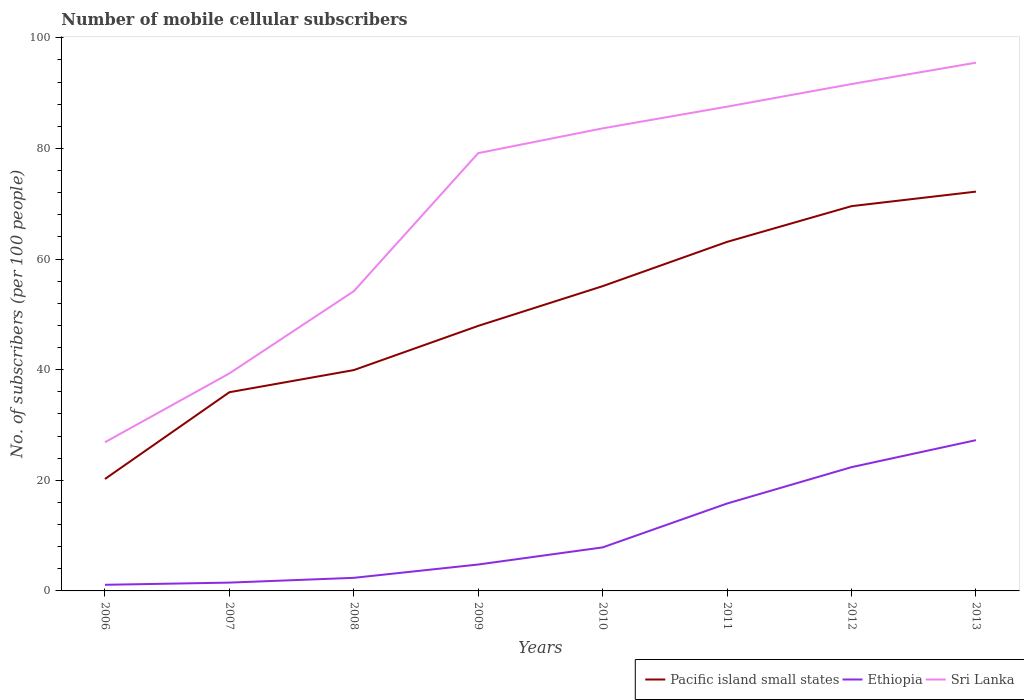Is the number of lines equal to the number of legend labels?
Provide a succinct answer. Yes. Across all years, what is the maximum number of mobile cellular subscribers in Sri Lanka?
Provide a short and direct response. 26.88. In which year was the number of mobile cellular subscribers in Sri Lanka maximum?
Your answer should be compact. 2006. What is the total number of mobile cellular subscribers in Ethiopia in the graph?
Offer a terse response. -22.48. What is the difference between the highest and the second highest number of mobile cellular subscribers in Pacific island small states?
Offer a very short reply. 51.95. What is the difference between the highest and the lowest number of mobile cellular subscribers in Pacific island small states?
Make the answer very short. 4. Is the number of mobile cellular subscribers in Pacific island small states strictly greater than the number of mobile cellular subscribers in Ethiopia over the years?
Provide a succinct answer. No. What is the difference between two consecutive major ticks on the Y-axis?
Give a very brief answer. 20. Are the values on the major ticks of Y-axis written in scientific E-notation?
Keep it short and to the point. No. Does the graph contain grids?
Ensure brevity in your answer.  No. Where does the legend appear in the graph?
Make the answer very short. Bottom right. What is the title of the graph?
Provide a succinct answer. Number of mobile cellular subscribers. Does "Nicaragua" appear as one of the legend labels in the graph?
Ensure brevity in your answer.  No. What is the label or title of the X-axis?
Your answer should be very brief. Years. What is the label or title of the Y-axis?
Offer a very short reply. No. of subscribers (per 100 people). What is the No. of subscribers (per 100 people) of Pacific island small states in 2006?
Offer a very short reply. 20.23. What is the No. of subscribers (per 100 people) of Ethiopia in 2006?
Your answer should be very brief. 1.11. What is the No. of subscribers (per 100 people) in Sri Lanka in 2006?
Your answer should be very brief. 26.88. What is the No. of subscribers (per 100 people) of Pacific island small states in 2007?
Provide a short and direct response. 35.92. What is the No. of subscribers (per 100 people) of Ethiopia in 2007?
Ensure brevity in your answer.  1.5. What is the No. of subscribers (per 100 people) of Sri Lanka in 2007?
Your response must be concise. 39.32. What is the No. of subscribers (per 100 people) of Pacific island small states in 2008?
Keep it short and to the point. 39.92. What is the No. of subscribers (per 100 people) of Ethiopia in 2008?
Provide a succinct answer. 2.37. What is the No. of subscribers (per 100 people) of Sri Lanka in 2008?
Your response must be concise. 54.19. What is the No. of subscribers (per 100 people) in Pacific island small states in 2009?
Ensure brevity in your answer.  47.92. What is the No. of subscribers (per 100 people) in Ethiopia in 2009?
Offer a terse response. 4.78. What is the No. of subscribers (per 100 people) of Sri Lanka in 2009?
Keep it short and to the point. 79.15. What is the No. of subscribers (per 100 people) in Pacific island small states in 2010?
Keep it short and to the point. 55.1. What is the No. of subscribers (per 100 people) of Ethiopia in 2010?
Provide a succinct answer. 7.87. What is the No. of subscribers (per 100 people) of Sri Lanka in 2010?
Offer a terse response. 83.62. What is the No. of subscribers (per 100 people) in Pacific island small states in 2011?
Your response must be concise. 63.1. What is the No. of subscribers (per 100 people) in Ethiopia in 2011?
Make the answer very short. 15.8. What is the No. of subscribers (per 100 people) in Sri Lanka in 2011?
Your response must be concise. 87.55. What is the No. of subscribers (per 100 people) of Pacific island small states in 2012?
Your response must be concise. 69.56. What is the No. of subscribers (per 100 people) of Ethiopia in 2012?
Give a very brief answer. 22.37. What is the No. of subscribers (per 100 people) in Sri Lanka in 2012?
Your answer should be very brief. 91.63. What is the No. of subscribers (per 100 people) in Pacific island small states in 2013?
Offer a very short reply. 72.18. What is the No. of subscribers (per 100 people) of Ethiopia in 2013?
Give a very brief answer. 27.25. What is the No. of subscribers (per 100 people) in Sri Lanka in 2013?
Make the answer very short. 95.5. Across all years, what is the maximum No. of subscribers (per 100 people) in Pacific island small states?
Offer a very short reply. 72.18. Across all years, what is the maximum No. of subscribers (per 100 people) of Ethiopia?
Provide a short and direct response. 27.25. Across all years, what is the maximum No. of subscribers (per 100 people) in Sri Lanka?
Offer a very short reply. 95.5. Across all years, what is the minimum No. of subscribers (per 100 people) of Pacific island small states?
Keep it short and to the point. 20.23. Across all years, what is the minimum No. of subscribers (per 100 people) in Ethiopia?
Make the answer very short. 1.11. Across all years, what is the minimum No. of subscribers (per 100 people) in Sri Lanka?
Provide a short and direct response. 26.88. What is the total No. of subscribers (per 100 people) of Pacific island small states in the graph?
Offer a terse response. 403.94. What is the total No. of subscribers (per 100 people) of Ethiopia in the graph?
Ensure brevity in your answer.  83.05. What is the total No. of subscribers (per 100 people) in Sri Lanka in the graph?
Your response must be concise. 557.83. What is the difference between the No. of subscribers (per 100 people) of Pacific island small states in 2006 and that in 2007?
Your answer should be very brief. -15.69. What is the difference between the No. of subscribers (per 100 people) in Ethiopia in 2006 and that in 2007?
Your answer should be compact. -0.4. What is the difference between the No. of subscribers (per 100 people) in Sri Lanka in 2006 and that in 2007?
Keep it short and to the point. -12.45. What is the difference between the No. of subscribers (per 100 people) of Pacific island small states in 2006 and that in 2008?
Offer a very short reply. -19.69. What is the difference between the No. of subscribers (per 100 people) of Ethiopia in 2006 and that in 2008?
Ensure brevity in your answer.  -1.26. What is the difference between the No. of subscribers (per 100 people) of Sri Lanka in 2006 and that in 2008?
Keep it short and to the point. -27.31. What is the difference between the No. of subscribers (per 100 people) in Pacific island small states in 2006 and that in 2009?
Keep it short and to the point. -27.68. What is the difference between the No. of subscribers (per 100 people) in Ethiopia in 2006 and that in 2009?
Provide a succinct answer. -3.67. What is the difference between the No. of subscribers (per 100 people) in Sri Lanka in 2006 and that in 2009?
Your answer should be compact. -52.27. What is the difference between the No. of subscribers (per 100 people) of Pacific island small states in 2006 and that in 2010?
Your answer should be very brief. -34.86. What is the difference between the No. of subscribers (per 100 people) in Ethiopia in 2006 and that in 2010?
Give a very brief answer. -6.76. What is the difference between the No. of subscribers (per 100 people) of Sri Lanka in 2006 and that in 2010?
Offer a terse response. -56.75. What is the difference between the No. of subscribers (per 100 people) of Pacific island small states in 2006 and that in 2011?
Offer a terse response. -42.87. What is the difference between the No. of subscribers (per 100 people) of Ethiopia in 2006 and that in 2011?
Provide a succinct answer. -14.7. What is the difference between the No. of subscribers (per 100 people) of Sri Lanka in 2006 and that in 2011?
Provide a short and direct response. -60.67. What is the difference between the No. of subscribers (per 100 people) in Pacific island small states in 2006 and that in 2012?
Keep it short and to the point. -49.33. What is the difference between the No. of subscribers (per 100 people) in Ethiopia in 2006 and that in 2012?
Your answer should be very brief. -21.27. What is the difference between the No. of subscribers (per 100 people) of Sri Lanka in 2006 and that in 2012?
Provide a succinct answer. -64.76. What is the difference between the No. of subscribers (per 100 people) in Pacific island small states in 2006 and that in 2013?
Offer a very short reply. -51.95. What is the difference between the No. of subscribers (per 100 people) of Ethiopia in 2006 and that in 2013?
Your answer should be compact. -26.15. What is the difference between the No. of subscribers (per 100 people) of Sri Lanka in 2006 and that in 2013?
Keep it short and to the point. -68.62. What is the difference between the No. of subscribers (per 100 people) in Pacific island small states in 2007 and that in 2008?
Make the answer very short. -4. What is the difference between the No. of subscribers (per 100 people) in Ethiopia in 2007 and that in 2008?
Give a very brief answer. -0.86. What is the difference between the No. of subscribers (per 100 people) of Sri Lanka in 2007 and that in 2008?
Your answer should be very brief. -14.86. What is the difference between the No. of subscribers (per 100 people) of Pacific island small states in 2007 and that in 2009?
Your response must be concise. -11.99. What is the difference between the No. of subscribers (per 100 people) in Ethiopia in 2007 and that in 2009?
Offer a terse response. -3.27. What is the difference between the No. of subscribers (per 100 people) in Sri Lanka in 2007 and that in 2009?
Make the answer very short. -39.82. What is the difference between the No. of subscribers (per 100 people) of Pacific island small states in 2007 and that in 2010?
Ensure brevity in your answer.  -19.18. What is the difference between the No. of subscribers (per 100 people) in Ethiopia in 2007 and that in 2010?
Your response must be concise. -6.37. What is the difference between the No. of subscribers (per 100 people) in Sri Lanka in 2007 and that in 2010?
Keep it short and to the point. -44.3. What is the difference between the No. of subscribers (per 100 people) in Pacific island small states in 2007 and that in 2011?
Your response must be concise. -27.18. What is the difference between the No. of subscribers (per 100 people) in Ethiopia in 2007 and that in 2011?
Offer a very short reply. -14.3. What is the difference between the No. of subscribers (per 100 people) in Sri Lanka in 2007 and that in 2011?
Provide a succinct answer. -48.22. What is the difference between the No. of subscribers (per 100 people) in Pacific island small states in 2007 and that in 2012?
Your answer should be very brief. -33.64. What is the difference between the No. of subscribers (per 100 people) of Ethiopia in 2007 and that in 2012?
Provide a short and direct response. -20.87. What is the difference between the No. of subscribers (per 100 people) of Sri Lanka in 2007 and that in 2012?
Ensure brevity in your answer.  -52.31. What is the difference between the No. of subscribers (per 100 people) in Pacific island small states in 2007 and that in 2013?
Offer a very short reply. -36.26. What is the difference between the No. of subscribers (per 100 people) of Ethiopia in 2007 and that in 2013?
Ensure brevity in your answer.  -25.75. What is the difference between the No. of subscribers (per 100 people) in Sri Lanka in 2007 and that in 2013?
Provide a succinct answer. -56.17. What is the difference between the No. of subscribers (per 100 people) of Pacific island small states in 2008 and that in 2009?
Give a very brief answer. -7.99. What is the difference between the No. of subscribers (per 100 people) of Ethiopia in 2008 and that in 2009?
Give a very brief answer. -2.41. What is the difference between the No. of subscribers (per 100 people) in Sri Lanka in 2008 and that in 2009?
Make the answer very short. -24.96. What is the difference between the No. of subscribers (per 100 people) of Pacific island small states in 2008 and that in 2010?
Provide a short and direct response. -15.18. What is the difference between the No. of subscribers (per 100 people) in Ethiopia in 2008 and that in 2010?
Your response must be concise. -5.5. What is the difference between the No. of subscribers (per 100 people) of Sri Lanka in 2008 and that in 2010?
Offer a terse response. -29.44. What is the difference between the No. of subscribers (per 100 people) of Pacific island small states in 2008 and that in 2011?
Your answer should be very brief. -23.18. What is the difference between the No. of subscribers (per 100 people) of Ethiopia in 2008 and that in 2011?
Keep it short and to the point. -13.44. What is the difference between the No. of subscribers (per 100 people) of Sri Lanka in 2008 and that in 2011?
Your answer should be compact. -33.36. What is the difference between the No. of subscribers (per 100 people) in Pacific island small states in 2008 and that in 2012?
Offer a very short reply. -29.64. What is the difference between the No. of subscribers (per 100 people) in Ethiopia in 2008 and that in 2012?
Provide a succinct answer. -20.01. What is the difference between the No. of subscribers (per 100 people) of Sri Lanka in 2008 and that in 2012?
Keep it short and to the point. -37.45. What is the difference between the No. of subscribers (per 100 people) in Pacific island small states in 2008 and that in 2013?
Offer a very short reply. -32.26. What is the difference between the No. of subscribers (per 100 people) of Ethiopia in 2008 and that in 2013?
Your answer should be very brief. -24.89. What is the difference between the No. of subscribers (per 100 people) of Sri Lanka in 2008 and that in 2013?
Your answer should be very brief. -41.31. What is the difference between the No. of subscribers (per 100 people) of Pacific island small states in 2009 and that in 2010?
Keep it short and to the point. -7.18. What is the difference between the No. of subscribers (per 100 people) in Ethiopia in 2009 and that in 2010?
Your answer should be compact. -3.09. What is the difference between the No. of subscribers (per 100 people) of Sri Lanka in 2009 and that in 2010?
Provide a succinct answer. -4.48. What is the difference between the No. of subscribers (per 100 people) in Pacific island small states in 2009 and that in 2011?
Your response must be concise. -15.19. What is the difference between the No. of subscribers (per 100 people) of Ethiopia in 2009 and that in 2011?
Ensure brevity in your answer.  -11.03. What is the difference between the No. of subscribers (per 100 people) of Sri Lanka in 2009 and that in 2011?
Provide a succinct answer. -8.4. What is the difference between the No. of subscribers (per 100 people) of Pacific island small states in 2009 and that in 2012?
Your response must be concise. -21.65. What is the difference between the No. of subscribers (per 100 people) of Ethiopia in 2009 and that in 2012?
Offer a terse response. -17.6. What is the difference between the No. of subscribers (per 100 people) of Sri Lanka in 2009 and that in 2012?
Keep it short and to the point. -12.49. What is the difference between the No. of subscribers (per 100 people) of Pacific island small states in 2009 and that in 2013?
Make the answer very short. -24.27. What is the difference between the No. of subscribers (per 100 people) in Ethiopia in 2009 and that in 2013?
Offer a very short reply. -22.48. What is the difference between the No. of subscribers (per 100 people) in Sri Lanka in 2009 and that in 2013?
Make the answer very short. -16.35. What is the difference between the No. of subscribers (per 100 people) in Pacific island small states in 2010 and that in 2011?
Keep it short and to the point. -8. What is the difference between the No. of subscribers (per 100 people) of Ethiopia in 2010 and that in 2011?
Keep it short and to the point. -7.93. What is the difference between the No. of subscribers (per 100 people) in Sri Lanka in 2010 and that in 2011?
Your response must be concise. -3.92. What is the difference between the No. of subscribers (per 100 people) in Pacific island small states in 2010 and that in 2012?
Offer a very short reply. -14.46. What is the difference between the No. of subscribers (per 100 people) of Ethiopia in 2010 and that in 2012?
Ensure brevity in your answer.  -14.51. What is the difference between the No. of subscribers (per 100 people) of Sri Lanka in 2010 and that in 2012?
Offer a terse response. -8.01. What is the difference between the No. of subscribers (per 100 people) in Pacific island small states in 2010 and that in 2013?
Your answer should be very brief. -17.09. What is the difference between the No. of subscribers (per 100 people) in Ethiopia in 2010 and that in 2013?
Your response must be concise. -19.39. What is the difference between the No. of subscribers (per 100 people) of Sri Lanka in 2010 and that in 2013?
Your answer should be compact. -11.87. What is the difference between the No. of subscribers (per 100 people) of Pacific island small states in 2011 and that in 2012?
Make the answer very short. -6.46. What is the difference between the No. of subscribers (per 100 people) of Ethiopia in 2011 and that in 2012?
Your answer should be compact. -6.57. What is the difference between the No. of subscribers (per 100 people) of Sri Lanka in 2011 and that in 2012?
Provide a short and direct response. -4.09. What is the difference between the No. of subscribers (per 100 people) of Pacific island small states in 2011 and that in 2013?
Your response must be concise. -9.08. What is the difference between the No. of subscribers (per 100 people) in Ethiopia in 2011 and that in 2013?
Your response must be concise. -11.45. What is the difference between the No. of subscribers (per 100 people) in Sri Lanka in 2011 and that in 2013?
Ensure brevity in your answer.  -7.95. What is the difference between the No. of subscribers (per 100 people) of Pacific island small states in 2012 and that in 2013?
Give a very brief answer. -2.62. What is the difference between the No. of subscribers (per 100 people) of Ethiopia in 2012 and that in 2013?
Give a very brief answer. -4.88. What is the difference between the No. of subscribers (per 100 people) of Sri Lanka in 2012 and that in 2013?
Your answer should be very brief. -3.86. What is the difference between the No. of subscribers (per 100 people) in Pacific island small states in 2006 and the No. of subscribers (per 100 people) in Ethiopia in 2007?
Your answer should be compact. 18.73. What is the difference between the No. of subscribers (per 100 people) of Pacific island small states in 2006 and the No. of subscribers (per 100 people) of Sri Lanka in 2007?
Make the answer very short. -19.09. What is the difference between the No. of subscribers (per 100 people) of Ethiopia in 2006 and the No. of subscribers (per 100 people) of Sri Lanka in 2007?
Ensure brevity in your answer.  -38.22. What is the difference between the No. of subscribers (per 100 people) in Pacific island small states in 2006 and the No. of subscribers (per 100 people) in Ethiopia in 2008?
Make the answer very short. 17.87. What is the difference between the No. of subscribers (per 100 people) of Pacific island small states in 2006 and the No. of subscribers (per 100 people) of Sri Lanka in 2008?
Your answer should be compact. -33.95. What is the difference between the No. of subscribers (per 100 people) in Ethiopia in 2006 and the No. of subscribers (per 100 people) in Sri Lanka in 2008?
Keep it short and to the point. -53.08. What is the difference between the No. of subscribers (per 100 people) of Pacific island small states in 2006 and the No. of subscribers (per 100 people) of Ethiopia in 2009?
Ensure brevity in your answer.  15.46. What is the difference between the No. of subscribers (per 100 people) in Pacific island small states in 2006 and the No. of subscribers (per 100 people) in Sri Lanka in 2009?
Give a very brief answer. -58.91. What is the difference between the No. of subscribers (per 100 people) of Ethiopia in 2006 and the No. of subscribers (per 100 people) of Sri Lanka in 2009?
Offer a terse response. -78.04. What is the difference between the No. of subscribers (per 100 people) of Pacific island small states in 2006 and the No. of subscribers (per 100 people) of Ethiopia in 2010?
Your response must be concise. 12.36. What is the difference between the No. of subscribers (per 100 people) of Pacific island small states in 2006 and the No. of subscribers (per 100 people) of Sri Lanka in 2010?
Provide a succinct answer. -63.39. What is the difference between the No. of subscribers (per 100 people) in Ethiopia in 2006 and the No. of subscribers (per 100 people) in Sri Lanka in 2010?
Ensure brevity in your answer.  -82.52. What is the difference between the No. of subscribers (per 100 people) of Pacific island small states in 2006 and the No. of subscribers (per 100 people) of Ethiopia in 2011?
Provide a succinct answer. 4.43. What is the difference between the No. of subscribers (per 100 people) of Pacific island small states in 2006 and the No. of subscribers (per 100 people) of Sri Lanka in 2011?
Keep it short and to the point. -67.31. What is the difference between the No. of subscribers (per 100 people) of Ethiopia in 2006 and the No. of subscribers (per 100 people) of Sri Lanka in 2011?
Make the answer very short. -86.44. What is the difference between the No. of subscribers (per 100 people) in Pacific island small states in 2006 and the No. of subscribers (per 100 people) in Ethiopia in 2012?
Your answer should be compact. -2.14. What is the difference between the No. of subscribers (per 100 people) in Pacific island small states in 2006 and the No. of subscribers (per 100 people) in Sri Lanka in 2012?
Your answer should be compact. -71.4. What is the difference between the No. of subscribers (per 100 people) in Ethiopia in 2006 and the No. of subscribers (per 100 people) in Sri Lanka in 2012?
Give a very brief answer. -90.53. What is the difference between the No. of subscribers (per 100 people) in Pacific island small states in 2006 and the No. of subscribers (per 100 people) in Ethiopia in 2013?
Provide a succinct answer. -7.02. What is the difference between the No. of subscribers (per 100 people) of Pacific island small states in 2006 and the No. of subscribers (per 100 people) of Sri Lanka in 2013?
Your answer should be very brief. -75.26. What is the difference between the No. of subscribers (per 100 people) in Ethiopia in 2006 and the No. of subscribers (per 100 people) in Sri Lanka in 2013?
Provide a succinct answer. -94.39. What is the difference between the No. of subscribers (per 100 people) in Pacific island small states in 2007 and the No. of subscribers (per 100 people) in Ethiopia in 2008?
Make the answer very short. 33.56. What is the difference between the No. of subscribers (per 100 people) in Pacific island small states in 2007 and the No. of subscribers (per 100 people) in Sri Lanka in 2008?
Provide a succinct answer. -18.26. What is the difference between the No. of subscribers (per 100 people) in Ethiopia in 2007 and the No. of subscribers (per 100 people) in Sri Lanka in 2008?
Ensure brevity in your answer.  -52.68. What is the difference between the No. of subscribers (per 100 people) of Pacific island small states in 2007 and the No. of subscribers (per 100 people) of Ethiopia in 2009?
Your answer should be very brief. 31.15. What is the difference between the No. of subscribers (per 100 people) in Pacific island small states in 2007 and the No. of subscribers (per 100 people) in Sri Lanka in 2009?
Offer a terse response. -43.22. What is the difference between the No. of subscribers (per 100 people) of Ethiopia in 2007 and the No. of subscribers (per 100 people) of Sri Lanka in 2009?
Provide a short and direct response. -77.64. What is the difference between the No. of subscribers (per 100 people) in Pacific island small states in 2007 and the No. of subscribers (per 100 people) in Ethiopia in 2010?
Provide a succinct answer. 28.05. What is the difference between the No. of subscribers (per 100 people) of Pacific island small states in 2007 and the No. of subscribers (per 100 people) of Sri Lanka in 2010?
Your answer should be very brief. -47.7. What is the difference between the No. of subscribers (per 100 people) in Ethiopia in 2007 and the No. of subscribers (per 100 people) in Sri Lanka in 2010?
Your answer should be very brief. -82.12. What is the difference between the No. of subscribers (per 100 people) in Pacific island small states in 2007 and the No. of subscribers (per 100 people) in Ethiopia in 2011?
Your response must be concise. 20.12. What is the difference between the No. of subscribers (per 100 people) in Pacific island small states in 2007 and the No. of subscribers (per 100 people) in Sri Lanka in 2011?
Ensure brevity in your answer.  -51.62. What is the difference between the No. of subscribers (per 100 people) of Ethiopia in 2007 and the No. of subscribers (per 100 people) of Sri Lanka in 2011?
Your response must be concise. -86.04. What is the difference between the No. of subscribers (per 100 people) in Pacific island small states in 2007 and the No. of subscribers (per 100 people) in Ethiopia in 2012?
Make the answer very short. 13.55. What is the difference between the No. of subscribers (per 100 people) in Pacific island small states in 2007 and the No. of subscribers (per 100 people) in Sri Lanka in 2012?
Offer a terse response. -55.71. What is the difference between the No. of subscribers (per 100 people) in Ethiopia in 2007 and the No. of subscribers (per 100 people) in Sri Lanka in 2012?
Provide a succinct answer. -90.13. What is the difference between the No. of subscribers (per 100 people) in Pacific island small states in 2007 and the No. of subscribers (per 100 people) in Ethiopia in 2013?
Provide a short and direct response. 8.67. What is the difference between the No. of subscribers (per 100 people) in Pacific island small states in 2007 and the No. of subscribers (per 100 people) in Sri Lanka in 2013?
Your answer should be compact. -59.57. What is the difference between the No. of subscribers (per 100 people) of Ethiopia in 2007 and the No. of subscribers (per 100 people) of Sri Lanka in 2013?
Ensure brevity in your answer.  -93.99. What is the difference between the No. of subscribers (per 100 people) of Pacific island small states in 2008 and the No. of subscribers (per 100 people) of Ethiopia in 2009?
Your answer should be very brief. 35.15. What is the difference between the No. of subscribers (per 100 people) of Pacific island small states in 2008 and the No. of subscribers (per 100 people) of Sri Lanka in 2009?
Give a very brief answer. -39.22. What is the difference between the No. of subscribers (per 100 people) of Ethiopia in 2008 and the No. of subscribers (per 100 people) of Sri Lanka in 2009?
Keep it short and to the point. -76.78. What is the difference between the No. of subscribers (per 100 people) of Pacific island small states in 2008 and the No. of subscribers (per 100 people) of Ethiopia in 2010?
Provide a succinct answer. 32.05. What is the difference between the No. of subscribers (per 100 people) of Pacific island small states in 2008 and the No. of subscribers (per 100 people) of Sri Lanka in 2010?
Ensure brevity in your answer.  -43.7. What is the difference between the No. of subscribers (per 100 people) in Ethiopia in 2008 and the No. of subscribers (per 100 people) in Sri Lanka in 2010?
Your answer should be very brief. -81.26. What is the difference between the No. of subscribers (per 100 people) in Pacific island small states in 2008 and the No. of subscribers (per 100 people) in Ethiopia in 2011?
Your answer should be very brief. 24.12. What is the difference between the No. of subscribers (per 100 people) of Pacific island small states in 2008 and the No. of subscribers (per 100 people) of Sri Lanka in 2011?
Ensure brevity in your answer.  -47.62. What is the difference between the No. of subscribers (per 100 people) of Ethiopia in 2008 and the No. of subscribers (per 100 people) of Sri Lanka in 2011?
Provide a succinct answer. -85.18. What is the difference between the No. of subscribers (per 100 people) in Pacific island small states in 2008 and the No. of subscribers (per 100 people) in Ethiopia in 2012?
Offer a very short reply. 17.55. What is the difference between the No. of subscribers (per 100 people) of Pacific island small states in 2008 and the No. of subscribers (per 100 people) of Sri Lanka in 2012?
Provide a succinct answer. -51.71. What is the difference between the No. of subscribers (per 100 people) of Ethiopia in 2008 and the No. of subscribers (per 100 people) of Sri Lanka in 2012?
Offer a terse response. -89.27. What is the difference between the No. of subscribers (per 100 people) of Pacific island small states in 2008 and the No. of subscribers (per 100 people) of Ethiopia in 2013?
Provide a succinct answer. 12.67. What is the difference between the No. of subscribers (per 100 people) of Pacific island small states in 2008 and the No. of subscribers (per 100 people) of Sri Lanka in 2013?
Provide a succinct answer. -55.57. What is the difference between the No. of subscribers (per 100 people) of Ethiopia in 2008 and the No. of subscribers (per 100 people) of Sri Lanka in 2013?
Offer a terse response. -93.13. What is the difference between the No. of subscribers (per 100 people) of Pacific island small states in 2009 and the No. of subscribers (per 100 people) of Ethiopia in 2010?
Provide a succinct answer. 40.05. What is the difference between the No. of subscribers (per 100 people) of Pacific island small states in 2009 and the No. of subscribers (per 100 people) of Sri Lanka in 2010?
Your response must be concise. -35.71. What is the difference between the No. of subscribers (per 100 people) in Ethiopia in 2009 and the No. of subscribers (per 100 people) in Sri Lanka in 2010?
Keep it short and to the point. -78.85. What is the difference between the No. of subscribers (per 100 people) of Pacific island small states in 2009 and the No. of subscribers (per 100 people) of Ethiopia in 2011?
Make the answer very short. 32.11. What is the difference between the No. of subscribers (per 100 people) in Pacific island small states in 2009 and the No. of subscribers (per 100 people) in Sri Lanka in 2011?
Your answer should be very brief. -39.63. What is the difference between the No. of subscribers (per 100 people) in Ethiopia in 2009 and the No. of subscribers (per 100 people) in Sri Lanka in 2011?
Your answer should be compact. -82.77. What is the difference between the No. of subscribers (per 100 people) in Pacific island small states in 2009 and the No. of subscribers (per 100 people) in Ethiopia in 2012?
Offer a terse response. 25.54. What is the difference between the No. of subscribers (per 100 people) in Pacific island small states in 2009 and the No. of subscribers (per 100 people) in Sri Lanka in 2012?
Keep it short and to the point. -43.72. What is the difference between the No. of subscribers (per 100 people) in Ethiopia in 2009 and the No. of subscribers (per 100 people) in Sri Lanka in 2012?
Offer a very short reply. -86.86. What is the difference between the No. of subscribers (per 100 people) in Pacific island small states in 2009 and the No. of subscribers (per 100 people) in Ethiopia in 2013?
Keep it short and to the point. 20.66. What is the difference between the No. of subscribers (per 100 people) in Pacific island small states in 2009 and the No. of subscribers (per 100 people) in Sri Lanka in 2013?
Ensure brevity in your answer.  -47.58. What is the difference between the No. of subscribers (per 100 people) in Ethiopia in 2009 and the No. of subscribers (per 100 people) in Sri Lanka in 2013?
Ensure brevity in your answer.  -90.72. What is the difference between the No. of subscribers (per 100 people) in Pacific island small states in 2010 and the No. of subscribers (per 100 people) in Ethiopia in 2011?
Ensure brevity in your answer.  39.29. What is the difference between the No. of subscribers (per 100 people) of Pacific island small states in 2010 and the No. of subscribers (per 100 people) of Sri Lanka in 2011?
Offer a very short reply. -32.45. What is the difference between the No. of subscribers (per 100 people) in Ethiopia in 2010 and the No. of subscribers (per 100 people) in Sri Lanka in 2011?
Ensure brevity in your answer.  -79.68. What is the difference between the No. of subscribers (per 100 people) in Pacific island small states in 2010 and the No. of subscribers (per 100 people) in Ethiopia in 2012?
Provide a short and direct response. 32.72. What is the difference between the No. of subscribers (per 100 people) in Pacific island small states in 2010 and the No. of subscribers (per 100 people) in Sri Lanka in 2012?
Offer a terse response. -36.54. What is the difference between the No. of subscribers (per 100 people) of Ethiopia in 2010 and the No. of subscribers (per 100 people) of Sri Lanka in 2012?
Keep it short and to the point. -83.76. What is the difference between the No. of subscribers (per 100 people) in Pacific island small states in 2010 and the No. of subscribers (per 100 people) in Ethiopia in 2013?
Ensure brevity in your answer.  27.84. What is the difference between the No. of subscribers (per 100 people) in Pacific island small states in 2010 and the No. of subscribers (per 100 people) in Sri Lanka in 2013?
Provide a succinct answer. -40.4. What is the difference between the No. of subscribers (per 100 people) in Ethiopia in 2010 and the No. of subscribers (per 100 people) in Sri Lanka in 2013?
Your answer should be very brief. -87.63. What is the difference between the No. of subscribers (per 100 people) in Pacific island small states in 2011 and the No. of subscribers (per 100 people) in Ethiopia in 2012?
Give a very brief answer. 40.73. What is the difference between the No. of subscribers (per 100 people) of Pacific island small states in 2011 and the No. of subscribers (per 100 people) of Sri Lanka in 2012?
Offer a terse response. -28.53. What is the difference between the No. of subscribers (per 100 people) in Ethiopia in 2011 and the No. of subscribers (per 100 people) in Sri Lanka in 2012?
Provide a short and direct response. -75.83. What is the difference between the No. of subscribers (per 100 people) of Pacific island small states in 2011 and the No. of subscribers (per 100 people) of Ethiopia in 2013?
Keep it short and to the point. 35.85. What is the difference between the No. of subscribers (per 100 people) in Pacific island small states in 2011 and the No. of subscribers (per 100 people) in Sri Lanka in 2013?
Your response must be concise. -32.4. What is the difference between the No. of subscribers (per 100 people) of Ethiopia in 2011 and the No. of subscribers (per 100 people) of Sri Lanka in 2013?
Offer a terse response. -79.69. What is the difference between the No. of subscribers (per 100 people) in Pacific island small states in 2012 and the No. of subscribers (per 100 people) in Ethiopia in 2013?
Make the answer very short. 42.31. What is the difference between the No. of subscribers (per 100 people) of Pacific island small states in 2012 and the No. of subscribers (per 100 people) of Sri Lanka in 2013?
Ensure brevity in your answer.  -25.93. What is the difference between the No. of subscribers (per 100 people) of Ethiopia in 2012 and the No. of subscribers (per 100 people) of Sri Lanka in 2013?
Offer a terse response. -73.12. What is the average No. of subscribers (per 100 people) in Pacific island small states per year?
Offer a terse response. 50.49. What is the average No. of subscribers (per 100 people) in Ethiopia per year?
Offer a terse response. 10.38. What is the average No. of subscribers (per 100 people) of Sri Lanka per year?
Offer a very short reply. 69.73. In the year 2006, what is the difference between the No. of subscribers (per 100 people) in Pacific island small states and No. of subscribers (per 100 people) in Ethiopia?
Offer a very short reply. 19.13. In the year 2006, what is the difference between the No. of subscribers (per 100 people) in Pacific island small states and No. of subscribers (per 100 people) in Sri Lanka?
Provide a succinct answer. -6.64. In the year 2006, what is the difference between the No. of subscribers (per 100 people) of Ethiopia and No. of subscribers (per 100 people) of Sri Lanka?
Ensure brevity in your answer.  -25.77. In the year 2007, what is the difference between the No. of subscribers (per 100 people) of Pacific island small states and No. of subscribers (per 100 people) of Ethiopia?
Offer a very short reply. 34.42. In the year 2007, what is the difference between the No. of subscribers (per 100 people) of Pacific island small states and No. of subscribers (per 100 people) of Sri Lanka?
Ensure brevity in your answer.  -3.4. In the year 2007, what is the difference between the No. of subscribers (per 100 people) of Ethiopia and No. of subscribers (per 100 people) of Sri Lanka?
Provide a short and direct response. -37.82. In the year 2008, what is the difference between the No. of subscribers (per 100 people) of Pacific island small states and No. of subscribers (per 100 people) of Ethiopia?
Provide a succinct answer. 37.56. In the year 2008, what is the difference between the No. of subscribers (per 100 people) in Pacific island small states and No. of subscribers (per 100 people) in Sri Lanka?
Provide a short and direct response. -14.26. In the year 2008, what is the difference between the No. of subscribers (per 100 people) in Ethiopia and No. of subscribers (per 100 people) in Sri Lanka?
Provide a succinct answer. -51.82. In the year 2009, what is the difference between the No. of subscribers (per 100 people) in Pacific island small states and No. of subscribers (per 100 people) in Ethiopia?
Provide a succinct answer. 43.14. In the year 2009, what is the difference between the No. of subscribers (per 100 people) in Pacific island small states and No. of subscribers (per 100 people) in Sri Lanka?
Offer a very short reply. -31.23. In the year 2009, what is the difference between the No. of subscribers (per 100 people) of Ethiopia and No. of subscribers (per 100 people) of Sri Lanka?
Give a very brief answer. -74.37. In the year 2010, what is the difference between the No. of subscribers (per 100 people) in Pacific island small states and No. of subscribers (per 100 people) in Ethiopia?
Provide a succinct answer. 47.23. In the year 2010, what is the difference between the No. of subscribers (per 100 people) of Pacific island small states and No. of subscribers (per 100 people) of Sri Lanka?
Your answer should be compact. -28.53. In the year 2010, what is the difference between the No. of subscribers (per 100 people) in Ethiopia and No. of subscribers (per 100 people) in Sri Lanka?
Keep it short and to the point. -75.75. In the year 2011, what is the difference between the No. of subscribers (per 100 people) in Pacific island small states and No. of subscribers (per 100 people) in Ethiopia?
Offer a very short reply. 47.3. In the year 2011, what is the difference between the No. of subscribers (per 100 people) in Pacific island small states and No. of subscribers (per 100 people) in Sri Lanka?
Offer a terse response. -24.44. In the year 2011, what is the difference between the No. of subscribers (per 100 people) in Ethiopia and No. of subscribers (per 100 people) in Sri Lanka?
Keep it short and to the point. -71.74. In the year 2012, what is the difference between the No. of subscribers (per 100 people) in Pacific island small states and No. of subscribers (per 100 people) in Ethiopia?
Your response must be concise. 47.19. In the year 2012, what is the difference between the No. of subscribers (per 100 people) in Pacific island small states and No. of subscribers (per 100 people) in Sri Lanka?
Offer a terse response. -22.07. In the year 2012, what is the difference between the No. of subscribers (per 100 people) in Ethiopia and No. of subscribers (per 100 people) in Sri Lanka?
Offer a terse response. -69.26. In the year 2013, what is the difference between the No. of subscribers (per 100 people) in Pacific island small states and No. of subscribers (per 100 people) in Ethiopia?
Provide a short and direct response. 44.93. In the year 2013, what is the difference between the No. of subscribers (per 100 people) of Pacific island small states and No. of subscribers (per 100 people) of Sri Lanka?
Your answer should be compact. -23.31. In the year 2013, what is the difference between the No. of subscribers (per 100 people) of Ethiopia and No. of subscribers (per 100 people) of Sri Lanka?
Offer a terse response. -68.24. What is the ratio of the No. of subscribers (per 100 people) in Pacific island small states in 2006 to that in 2007?
Your response must be concise. 0.56. What is the ratio of the No. of subscribers (per 100 people) in Ethiopia in 2006 to that in 2007?
Make the answer very short. 0.74. What is the ratio of the No. of subscribers (per 100 people) of Sri Lanka in 2006 to that in 2007?
Offer a terse response. 0.68. What is the ratio of the No. of subscribers (per 100 people) in Pacific island small states in 2006 to that in 2008?
Make the answer very short. 0.51. What is the ratio of the No. of subscribers (per 100 people) of Ethiopia in 2006 to that in 2008?
Your answer should be very brief. 0.47. What is the ratio of the No. of subscribers (per 100 people) in Sri Lanka in 2006 to that in 2008?
Your answer should be very brief. 0.5. What is the ratio of the No. of subscribers (per 100 people) in Pacific island small states in 2006 to that in 2009?
Keep it short and to the point. 0.42. What is the ratio of the No. of subscribers (per 100 people) in Ethiopia in 2006 to that in 2009?
Offer a terse response. 0.23. What is the ratio of the No. of subscribers (per 100 people) of Sri Lanka in 2006 to that in 2009?
Give a very brief answer. 0.34. What is the ratio of the No. of subscribers (per 100 people) in Pacific island small states in 2006 to that in 2010?
Provide a short and direct response. 0.37. What is the ratio of the No. of subscribers (per 100 people) of Ethiopia in 2006 to that in 2010?
Provide a short and direct response. 0.14. What is the ratio of the No. of subscribers (per 100 people) of Sri Lanka in 2006 to that in 2010?
Your response must be concise. 0.32. What is the ratio of the No. of subscribers (per 100 people) of Pacific island small states in 2006 to that in 2011?
Provide a succinct answer. 0.32. What is the ratio of the No. of subscribers (per 100 people) in Ethiopia in 2006 to that in 2011?
Your answer should be very brief. 0.07. What is the ratio of the No. of subscribers (per 100 people) of Sri Lanka in 2006 to that in 2011?
Offer a very short reply. 0.31. What is the ratio of the No. of subscribers (per 100 people) in Pacific island small states in 2006 to that in 2012?
Keep it short and to the point. 0.29. What is the ratio of the No. of subscribers (per 100 people) of Ethiopia in 2006 to that in 2012?
Ensure brevity in your answer.  0.05. What is the ratio of the No. of subscribers (per 100 people) of Sri Lanka in 2006 to that in 2012?
Provide a succinct answer. 0.29. What is the ratio of the No. of subscribers (per 100 people) in Pacific island small states in 2006 to that in 2013?
Offer a very short reply. 0.28. What is the ratio of the No. of subscribers (per 100 people) of Ethiopia in 2006 to that in 2013?
Give a very brief answer. 0.04. What is the ratio of the No. of subscribers (per 100 people) in Sri Lanka in 2006 to that in 2013?
Your answer should be compact. 0.28. What is the ratio of the No. of subscribers (per 100 people) in Pacific island small states in 2007 to that in 2008?
Your answer should be compact. 0.9. What is the ratio of the No. of subscribers (per 100 people) of Ethiopia in 2007 to that in 2008?
Your answer should be very brief. 0.64. What is the ratio of the No. of subscribers (per 100 people) of Sri Lanka in 2007 to that in 2008?
Make the answer very short. 0.73. What is the ratio of the No. of subscribers (per 100 people) in Pacific island small states in 2007 to that in 2009?
Your answer should be very brief. 0.75. What is the ratio of the No. of subscribers (per 100 people) in Ethiopia in 2007 to that in 2009?
Offer a very short reply. 0.31. What is the ratio of the No. of subscribers (per 100 people) in Sri Lanka in 2007 to that in 2009?
Provide a succinct answer. 0.5. What is the ratio of the No. of subscribers (per 100 people) in Pacific island small states in 2007 to that in 2010?
Provide a short and direct response. 0.65. What is the ratio of the No. of subscribers (per 100 people) in Ethiopia in 2007 to that in 2010?
Offer a very short reply. 0.19. What is the ratio of the No. of subscribers (per 100 people) of Sri Lanka in 2007 to that in 2010?
Offer a terse response. 0.47. What is the ratio of the No. of subscribers (per 100 people) in Pacific island small states in 2007 to that in 2011?
Your response must be concise. 0.57. What is the ratio of the No. of subscribers (per 100 people) of Ethiopia in 2007 to that in 2011?
Keep it short and to the point. 0.1. What is the ratio of the No. of subscribers (per 100 people) in Sri Lanka in 2007 to that in 2011?
Keep it short and to the point. 0.45. What is the ratio of the No. of subscribers (per 100 people) of Pacific island small states in 2007 to that in 2012?
Make the answer very short. 0.52. What is the ratio of the No. of subscribers (per 100 people) in Ethiopia in 2007 to that in 2012?
Give a very brief answer. 0.07. What is the ratio of the No. of subscribers (per 100 people) in Sri Lanka in 2007 to that in 2012?
Provide a short and direct response. 0.43. What is the ratio of the No. of subscribers (per 100 people) of Pacific island small states in 2007 to that in 2013?
Make the answer very short. 0.5. What is the ratio of the No. of subscribers (per 100 people) of Ethiopia in 2007 to that in 2013?
Provide a short and direct response. 0.06. What is the ratio of the No. of subscribers (per 100 people) of Sri Lanka in 2007 to that in 2013?
Your response must be concise. 0.41. What is the ratio of the No. of subscribers (per 100 people) of Pacific island small states in 2008 to that in 2009?
Make the answer very short. 0.83. What is the ratio of the No. of subscribers (per 100 people) in Ethiopia in 2008 to that in 2009?
Provide a short and direct response. 0.5. What is the ratio of the No. of subscribers (per 100 people) of Sri Lanka in 2008 to that in 2009?
Your answer should be very brief. 0.68. What is the ratio of the No. of subscribers (per 100 people) in Pacific island small states in 2008 to that in 2010?
Provide a succinct answer. 0.72. What is the ratio of the No. of subscribers (per 100 people) of Ethiopia in 2008 to that in 2010?
Make the answer very short. 0.3. What is the ratio of the No. of subscribers (per 100 people) in Sri Lanka in 2008 to that in 2010?
Offer a terse response. 0.65. What is the ratio of the No. of subscribers (per 100 people) in Pacific island small states in 2008 to that in 2011?
Offer a terse response. 0.63. What is the ratio of the No. of subscribers (per 100 people) in Ethiopia in 2008 to that in 2011?
Provide a succinct answer. 0.15. What is the ratio of the No. of subscribers (per 100 people) in Sri Lanka in 2008 to that in 2011?
Your response must be concise. 0.62. What is the ratio of the No. of subscribers (per 100 people) of Pacific island small states in 2008 to that in 2012?
Ensure brevity in your answer.  0.57. What is the ratio of the No. of subscribers (per 100 people) in Ethiopia in 2008 to that in 2012?
Give a very brief answer. 0.11. What is the ratio of the No. of subscribers (per 100 people) in Sri Lanka in 2008 to that in 2012?
Give a very brief answer. 0.59. What is the ratio of the No. of subscribers (per 100 people) in Pacific island small states in 2008 to that in 2013?
Offer a terse response. 0.55. What is the ratio of the No. of subscribers (per 100 people) in Ethiopia in 2008 to that in 2013?
Keep it short and to the point. 0.09. What is the ratio of the No. of subscribers (per 100 people) of Sri Lanka in 2008 to that in 2013?
Give a very brief answer. 0.57. What is the ratio of the No. of subscribers (per 100 people) of Pacific island small states in 2009 to that in 2010?
Keep it short and to the point. 0.87. What is the ratio of the No. of subscribers (per 100 people) in Ethiopia in 2009 to that in 2010?
Give a very brief answer. 0.61. What is the ratio of the No. of subscribers (per 100 people) of Sri Lanka in 2009 to that in 2010?
Provide a succinct answer. 0.95. What is the ratio of the No. of subscribers (per 100 people) of Pacific island small states in 2009 to that in 2011?
Offer a very short reply. 0.76. What is the ratio of the No. of subscribers (per 100 people) of Ethiopia in 2009 to that in 2011?
Keep it short and to the point. 0.3. What is the ratio of the No. of subscribers (per 100 people) of Sri Lanka in 2009 to that in 2011?
Provide a succinct answer. 0.9. What is the ratio of the No. of subscribers (per 100 people) in Pacific island small states in 2009 to that in 2012?
Your response must be concise. 0.69. What is the ratio of the No. of subscribers (per 100 people) of Ethiopia in 2009 to that in 2012?
Your answer should be very brief. 0.21. What is the ratio of the No. of subscribers (per 100 people) of Sri Lanka in 2009 to that in 2012?
Give a very brief answer. 0.86. What is the ratio of the No. of subscribers (per 100 people) of Pacific island small states in 2009 to that in 2013?
Your response must be concise. 0.66. What is the ratio of the No. of subscribers (per 100 people) of Ethiopia in 2009 to that in 2013?
Give a very brief answer. 0.18. What is the ratio of the No. of subscribers (per 100 people) of Sri Lanka in 2009 to that in 2013?
Keep it short and to the point. 0.83. What is the ratio of the No. of subscribers (per 100 people) of Pacific island small states in 2010 to that in 2011?
Give a very brief answer. 0.87. What is the ratio of the No. of subscribers (per 100 people) of Ethiopia in 2010 to that in 2011?
Ensure brevity in your answer.  0.5. What is the ratio of the No. of subscribers (per 100 people) in Sri Lanka in 2010 to that in 2011?
Provide a succinct answer. 0.96. What is the ratio of the No. of subscribers (per 100 people) in Pacific island small states in 2010 to that in 2012?
Your answer should be very brief. 0.79. What is the ratio of the No. of subscribers (per 100 people) in Ethiopia in 2010 to that in 2012?
Offer a terse response. 0.35. What is the ratio of the No. of subscribers (per 100 people) in Sri Lanka in 2010 to that in 2012?
Ensure brevity in your answer.  0.91. What is the ratio of the No. of subscribers (per 100 people) of Pacific island small states in 2010 to that in 2013?
Your answer should be compact. 0.76. What is the ratio of the No. of subscribers (per 100 people) in Ethiopia in 2010 to that in 2013?
Provide a succinct answer. 0.29. What is the ratio of the No. of subscribers (per 100 people) of Sri Lanka in 2010 to that in 2013?
Your answer should be compact. 0.88. What is the ratio of the No. of subscribers (per 100 people) of Pacific island small states in 2011 to that in 2012?
Offer a terse response. 0.91. What is the ratio of the No. of subscribers (per 100 people) of Ethiopia in 2011 to that in 2012?
Provide a short and direct response. 0.71. What is the ratio of the No. of subscribers (per 100 people) of Sri Lanka in 2011 to that in 2012?
Offer a very short reply. 0.96. What is the ratio of the No. of subscribers (per 100 people) in Pacific island small states in 2011 to that in 2013?
Provide a succinct answer. 0.87. What is the ratio of the No. of subscribers (per 100 people) of Ethiopia in 2011 to that in 2013?
Provide a succinct answer. 0.58. What is the ratio of the No. of subscribers (per 100 people) in Sri Lanka in 2011 to that in 2013?
Make the answer very short. 0.92. What is the ratio of the No. of subscribers (per 100 people) of Pacific island small states in 2012 to that in 2013?
Ensure brevity in your answer.  0.96. What is the ratio of the No. of subscribers (per 100 people) in Ethiopia in 2012 to that in 2013?
Offer a very short reply. 0.82. What is the ratio of the No. of subscribers (per 100 people) of Sri Lanka in 2012 to that in 2013?
Provide a succinct answer. 0.96. What is the difference between the highest and the second highest No. of subscribers (per 100 people) in Pacific island small states?
Your response must be concise. 2.62. What is the difference between the highest and the second highest No. of subscribers (per 100 people) in Ethiopia?
Your answer should be very brief. 4.88. What is the difference between the highest and the second highest No. of subscribers (per 100 people) in Sri Lanka?
Provide a short and direct response. 3.86. What is the difference between the highest and the lowest No. of subscribers (per 100 people) of Pacific island small states?
Give a very brief answer. 51.95. What is the difference between the highest and the lowest No. of subscribers (per 100 people) of Ethiopia?
Keep it short and to the point. 26.15. What is the difference between the highest and the lowest No. of subscribers (per 100 people) in Sri Lanka?
Make the answer very short. 68.62. 